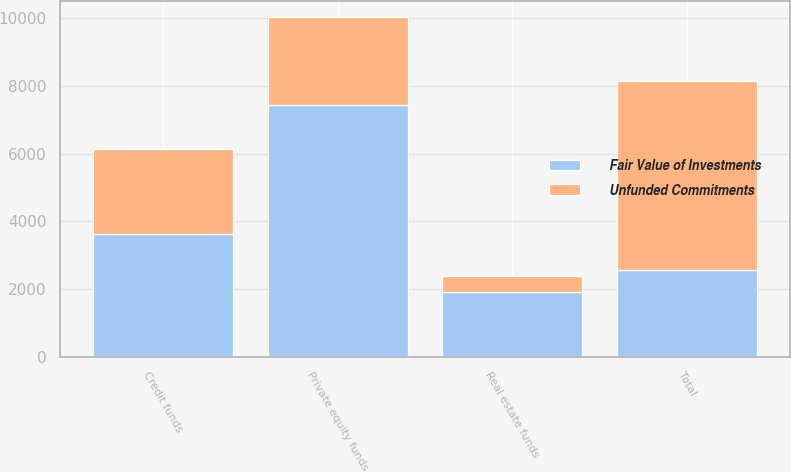Convert chart. <chart><loc_0><loc_0><loc_500><loc_500><stacked_bar_chart><ecel><fcel>Private equity funds<fcel>Credit funds<fcel>Real estate funds<fcel>Total<nl><fcel>Fair Value of Investments<fcel>7446<fcel>3624<fcel>1908<fcel>2575<nl><fcel>Unfunded Commitments<fcel>2575<fcel>2515<fcel>471<fcel>5561<nl></chart> 